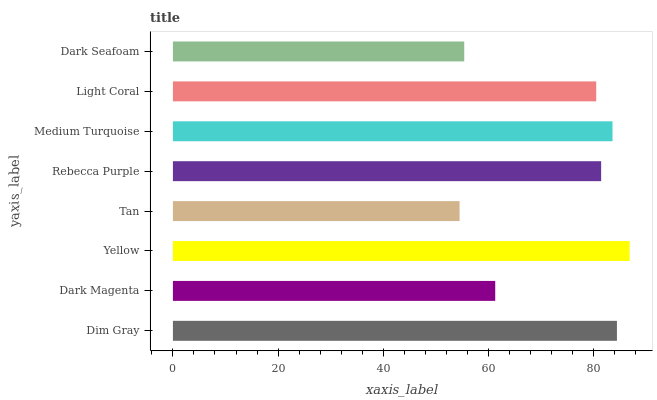Is Tan the minimum?
Answer yes or no. Yes. Is Yellow the maximum?
Answer yes or no. Yes. Is Dark Magenta the minimum?
Answer yes or no. No. Is Dark Magenta the maximum?
Answer yes or no. No. Is Dim Gray greater than Dark Magenta?
Answer yes or no. Yes. Is Dark Magenta less than Dim Gray?
Answer yes or no. Yes. Is Dark Magenta greater than Dim Gray?
Answer yes or no. No. Is Dim Gray less than Dark Magenta?
Answer yes or no. No. Is Rebecca Purple the high median?
Answer yes or no. Yes. Is Light Coral the low median?
Answer yes or no. Yes. Is Dark Seafoam the high median?
Answer yes or no. No. Is Dark Seafoam the low median?
Answer yes or no. No. 